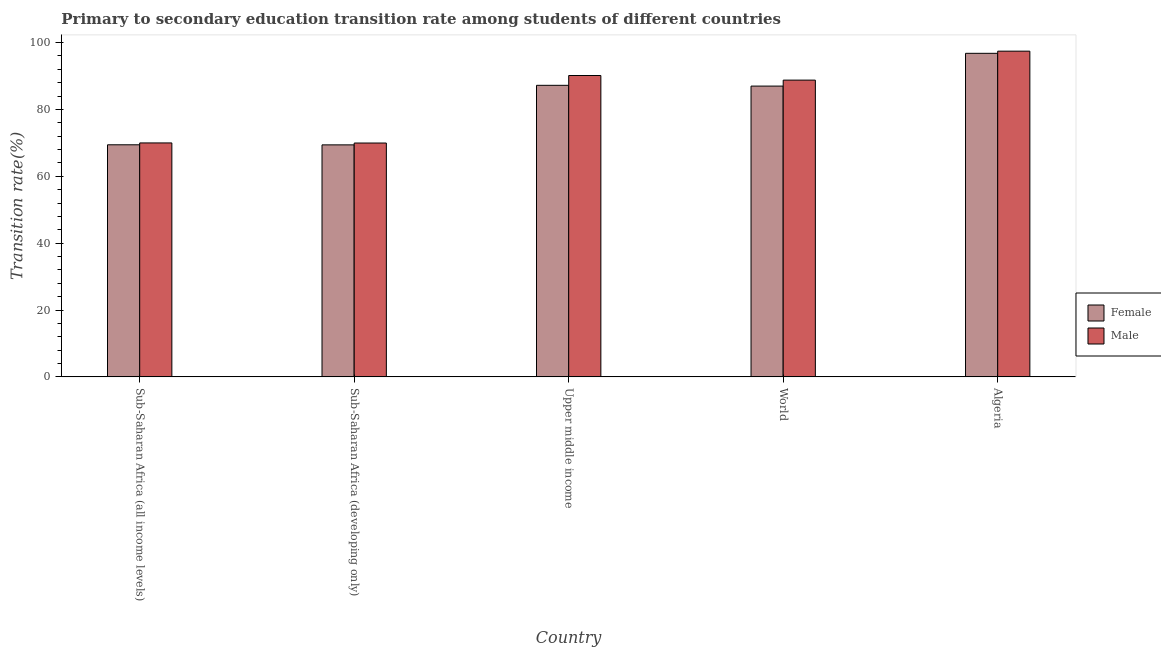How many groups of bars are there?
Provide a short and direct response. 5. Are the number of bars per tick equal to the number of legend labels?
Offer a terse response. Yes. Are the number of bars on each tick of the X-axis equal?
Keep it short and to the point. Yes. How many bars are there on the 4th tick from the left?
Offer a very short reply. 2. How many bars are there on the 1st tick from the right?
Offer a terse response. 2. What is the label of the 1st group of bars from the left?
Provide a short and direct response. Sub-Saharan Africa (all income levels). In how many cases, is the number of bars for a given country not equal to the number of legend labels?
Keep it short and to the point. 0. What is the transition rate among female students in Upper middle income?
Give a very brief answer. 87.21. Across all countries, what is the maximum transition rate among male students?
Offer a very short reply. 97.42. Across all countries, what is the minimum transition rate among male students?
Your answer should be compact. 69.95. In which country was the transition rate among male students maximum?
Keep it short and to the point. Algeria. In which country was the transition rate among male students minimum?
Keep it short and to the point. Sub-Saharan Africa (developing only). What is the total transition rate among male students in the graph?
Make the answer very short. 416.25. What is the difference between the transition rate among male students in Sub-Saharan Africa (developing only) and that in World?
Make the answer very short. -18.81. What is the difference between the transition rate among male students in Algeria and the transition rate among female students in World?
Your answer should be compact. 10.45. What is the average transition rate among female students per country?
Your response must be concise. 81.96. What is the difference between the transition rate among female students and transition rate among male students in Sub-Saharan Africa (developing only)?
Your answer should be compact. -0.55. In how many countries, is the transition rate among female students greater than 24 %?
Ensure brevity in your answer.  5. What is the ratio of the transition rate among female students in Sub-Saharan Africa (all income levels) to that in Sub-Saharan Africa (developing only)?
Ensure brevity in your answer.  1. What is the difference between the highest and the second highest transition rate among female students?
Your answer should be compact. 9.57. What is the difference between the highest and the lowest transition rate among male students?
Make the answer very short. 27.48. What does the 1st bar from the right in Sub-Saharan Africa (all income levels) represents?
Offer a terse response. Male. Are all the bars in the graph horizontal?
Offer a terse response. No. Are the values on the major ticks of Y-axis written in scientific E-notation?
Give a very brief answer. No. How are the legend labels stacked?
Provide a short and direct response. Vertical. What is the title of the graph?
Provide a succinct answer. Primary to secondary education transition rate among students of different countries. Does "Secondary school" appear as one of the legend labels in the graph?
Ensure brevity in your answer.  No. What is the label or title of the Y-axis?
Offer a terse response. Transition rate(%). What is the Transition rate(%) in Female in Sub-Saharan Africa (all income levels)?
Give a very brief answer. 69.42. What is the Transition rate(%) of Male in Sub-Saharan Africa (all income levels)?
Offer a very short reply. 69.97. What is the Transition rate(%) in Female in Sub-Saharan Africa (developing only)?
Offer a terse response. 69.39. What is the Transition rate(%) in Male in Sub-Saharan Africa (developing only)?
Keep it short and to the point. 69.95. What is the Transition rate(%) in Female in Upper middle income?
Make the answer very short. 87.21. What is the Transition rate(%) in Male in Upper middle income?
Your answer should be very brief. 90.14. What is the Transition rate(%) of Female in World?
Keep it short and to the point. 86.98. What is the Transition rate(%) of Male in World?
Your answer should be compact. 88.76. What is the Transition rate(%) in Female in Algeria?
Give a very brief answer. 96.78. What is the Transition rate(%) of Male in Algeria?
Ensure brevity in your answer.  97.42. Across all countries, what is the maximum Transition rate(%) in Female?
Give a very brief answer. 96.78. Across all countries, what is the maximum Transition rate(%) in Male?
Your answer should be compact. 97.42. Across all countries, what is the minimum Transition rate(%) of Female?
Provide a short and direct response. 69.39. Across all countries, what is the minimum Transition rate(%) of Male?
Offer a very short reply. 69.95. What is the total Transition rate(%) in Female in the graph?
Your response must be concise. 409.78. What is the total Transition rate(%) in Male in the graph?
Give a very brief answer. 416.25. What is the difference between the Transition rate(%) of Female in Sub-Saharan Africa (all income levels) and that in Sub-Saharan Africa (developing only)?
Give a very brief answer. 0.02. What is the difference between the Transition rate(%) of Male in Sub-Saharan Africa (all income levels) and that in Sub-Saharan Africa (developing only)?
Your answer should be very brief. 0.03. What is the difference between the Transition rate(%) of Female in Sub-Saharan Africa (all income levels) and that in Upper middle income?
Your answer should be compact. -17.79. What is the difference between the Transition rate(%) of Male in Sub-Saharan Africa (all income levels) and that in Upper middle income?
Offer a terse response. -20.17. What is the difference between the Transition rate(%) of Female in Sub-Saharan Africa (all income levels) and that in World?
Offer a very short reply. -17.56. What is the difference between the Transition rate(%) of Male in Sub-Saharan Africa (all income levels) and that in World?
Make the answer very short. -18.79. What is the difference between the Transition rate(%) of Female in Sub-Saharan Africa (all income levels) and that in Algeria?
Give a very brief answer. -27.36. What is the difference between the Transition rate(%) in Male in Sub-Saharan Africa (all income levels) and that in Algeria?
Your response must be concise. -27.45. What is the difference between the Transition rate(%) in Female in Sub-Saharan Africa (developing only) and that in Upper middle income?
Provide a succinct answer. -17.81. What is the difference between the Transition rate(%) in Male in Sub-Saharan Africa (developing only) and that in Upper middle income?
Make the answer very short. -20.19. What is the difference between the Transition rate(%) of Female in Sub-Saharan Africa (developing only) and that in World?
Your answer should be very brief. -17.58. What is the difference between the Transition rate(%) of Male in Sub-Saharan Africa (developing only) and that in World?
Provide a succinct answer. -18.81. What is the difference between the Transition rate(%) of Female in Sub-Saharan Africa (developing only) and that in Algeria?
Keep it short and to the point. -27.39. What is the difference between the Transition rate(%) in Male in Sub-Saharan Africa (developing only) and that in Algeria?
Keep it short and to the point. -27.48. What is the difference between the Transition rate(%) in Female in Upper middle income and that in World?
Make the answer very short. 0.23. What is the difference between the Transition rate(%) of Male in Upper middle income and that in World?
Offer a very short reply. 1.38. What is the difference between the Transition rate(%) of Female in Upper middle income and that in Algeria?
Provide a succinct answer. -9.57. What is the difference between the Transition rate(%) in Male in Upper middle income and that in Algeria?
Offer a terse response. -7.28. What is the difference between the Transition rate(%) in Female in World and that in Algeria?
Your answer should be very brief. -9.8. What is the difference between the Transition rate(%) of Male in World and that in Algeria?
Keep it short and to the point. -8.66. What is the difference between the Transition rate(%) in Female in Sub-Saharan Africa (all income levels) and the Transition rate(%) in Male in Sub-Saharan Africa (developing only)?
Provide a short and direct response. -0.53. What is the difference between the Transition rate(%) of Female in Sub-Saharan Africa (all income levels) and the Transition rate(%) of Male in Upper middle income?
Your answer should be very brief. -20.72. What is the difference between the Transition rate(%) of Female in Sub-Saharan Africa (all income levels) and the Transition rate(%) of Male in World?
Your answer should be compact. -19.34. What is the difference between the Transition rate(%) of Female in Sub-Saharan Africa (all income levels) and the Transition rate(%) of Male in Algeria?
Your response must be concise. -28.01. What is the difference between the Transition rate(%) in Female in Sub-Saharan Africa (developing only) and the Transition rate(%) in Male in Upper middle income?
Offer a terse response. -20.75. What is the difference between the Transition rate(%) of Female in Sub-Saharan Africa (developing only) and the Transition rate(%) of Male in World?
Provide a short and direct response. -19.37. What is the difference between the Transition rate(%) in Female in Sub-Saharan Africa (developing only) and the Transition rate(%) in Male in Algeria?
Provide a succinct answer. -28.03. What is the difference between the Transition rate(%) of Female in Upper middle income and the Transition rate(%) of Male in World?
Keep it short and to the point. -1.56. What is the difference between the Transition rate(%) of Female in Upper middle income and the Transition rate(%) of Male in Algeria?
Offer a very short reply. -10.22. What is the difference between the Transition rate(%) in Female in World and the Transition rate(%) in Male in Algeria?
Offer a very short reply. -10.45. What is the average Transition rate(%) of Female per country?
Your answer should be compact. 81.96. What is the average Transition rate(%) in Male per country?
Your response must be concise. 83.25. What is the difference between the Transition rate(%) in Female and Transition rate(%) in Male in Sub-Saharan Africa (all income levels)?
Give a very brief answer. -0.56. What is the difference between the Transition rate(%) in Female and Transition rate(%) in Male in Sub-Saharan Africa (developing only)?
Make the answer very short. -0.55. What is the difference between the Transition rate(%) in Female and Transition rate(%) in Male in Upper middle income?
Give a very brief answer. -2.93. What is the difference between the Transition rate(%) of Female and Transition rate(%) of Male in World?
Provide a succinct answer. -1.78. What is the difference between the Transition rate(%) in Female and Transition rate(%) in Male in Algeria?
Ensure brevity in your answer.  -0.64. What is the ratio of the Transition rate(%) in Female in Sub-Saharan Africa (all income levels) to that in Sub-Saharan Africa (developing only)?
Offer a terse response. 1. What is the ratio of the Transition rate(%) in Male in Sub-Saharan Africa (all income levels) to that in Sub-Saharan Africa (developing only)?
Provide a short and direct response. 1. What is the ratio of the Transition rate(%) in Female in Sub-Saharan Africa (all income levels) to that in Upper middle income?
Provide a short and direct response. 0.8. What is the ratio of the Transition rate(%) in Male in Sub-Saharan Africa (all income levels) to that in Upper middle income?
Offer a very short reply. 0.78. What is the ratio of the Transition rate(%) of Female in Sub-Saharan Africa (all income levels) to that in World?
Your response must be concise. 0.8. What is the ratio of the Transition rate(%) of Male in Sub-Saharan Africa (all income levels) to that in World?
Give a very brief answer. 0.79. What is the ratio of the Transition rate(%) of Female in Sub-Saharan Africa (all income levels) to that in Algeria?
Provide a succinct answer. 0.72. What is the ratio of the Transition rate(%) of Male in Sub-Saharan Africa (all income levels) to that in Algeria?
Make the answer very short. 0.72. What is the ratio of the Transition rate(%) in Female in Sub-Saharan Africa (developing only) to that in Upper middle income?
Keep it short and to the point. 0.8. What is the ratio of the Transition rate(%) of Male in Sub-Saharan Africa (developing only) to that in Upper middle income?
Make the answer very short. 0.78. What is the ratio of the Transition rate(%) of Female in Sub-Saharan Africa (developing only) to that in World?
Your answer should be very brief. 0.8. What is the ratio of the Transition rate(%) in Male in Sub-Saharan Africa (developing only) to that in World?
Keep it short and to the point. 0.79. What is the ratio of the Transition rate(%) in Female in Sub-Saharan Africa (developing only) to that in Algeria?
Offer a terse response. 0.72. What is the ratio of the Transition rate(%) in Male in Sub-Saharan Africa (developing only) to that in Algeria?
Give a very brief answer. 0.72. What is the ratio of the Transition rate(%) of Female in Upper middle income to that in World?
Your answer should be compact. 1. What is the ratio of the Transition rate(%) in Male in Upper middle income to that in World?
Offer a very short reply. 1.02. What is the ratio of the Transition rate(%) in Female in Upper middle income to that in Algeria?
Keep it short and to the point. 0.9. What is the ratio of the Transition rate(%) in Male in Upper middle income to that in Algeria?
Your response must be concise. 0.93. What is the ratio of the Transition rate(%) in Female in World to that in Algeria?
Provide a succinct answer. 0.9. What is the ratio of the Transition rate(%) of Male in World to that in Algeria?
Keep it short and to the point. 0.91. What is the difference between the highest and the second highest Transition rate(%) in Female?
Keep it short and to the point. 9.57. What is the difference between the highest and the second highest Transition rate(%) in Male?
Make the answer very short. 7.28. What is the difference between the highest and the lowest Transition rate(%) in Female?
Your response must be concise. 27.39. What is the difference between the highest and the lowest Transition rate(%) of Male?
Give a very brief answer. 27.48. 